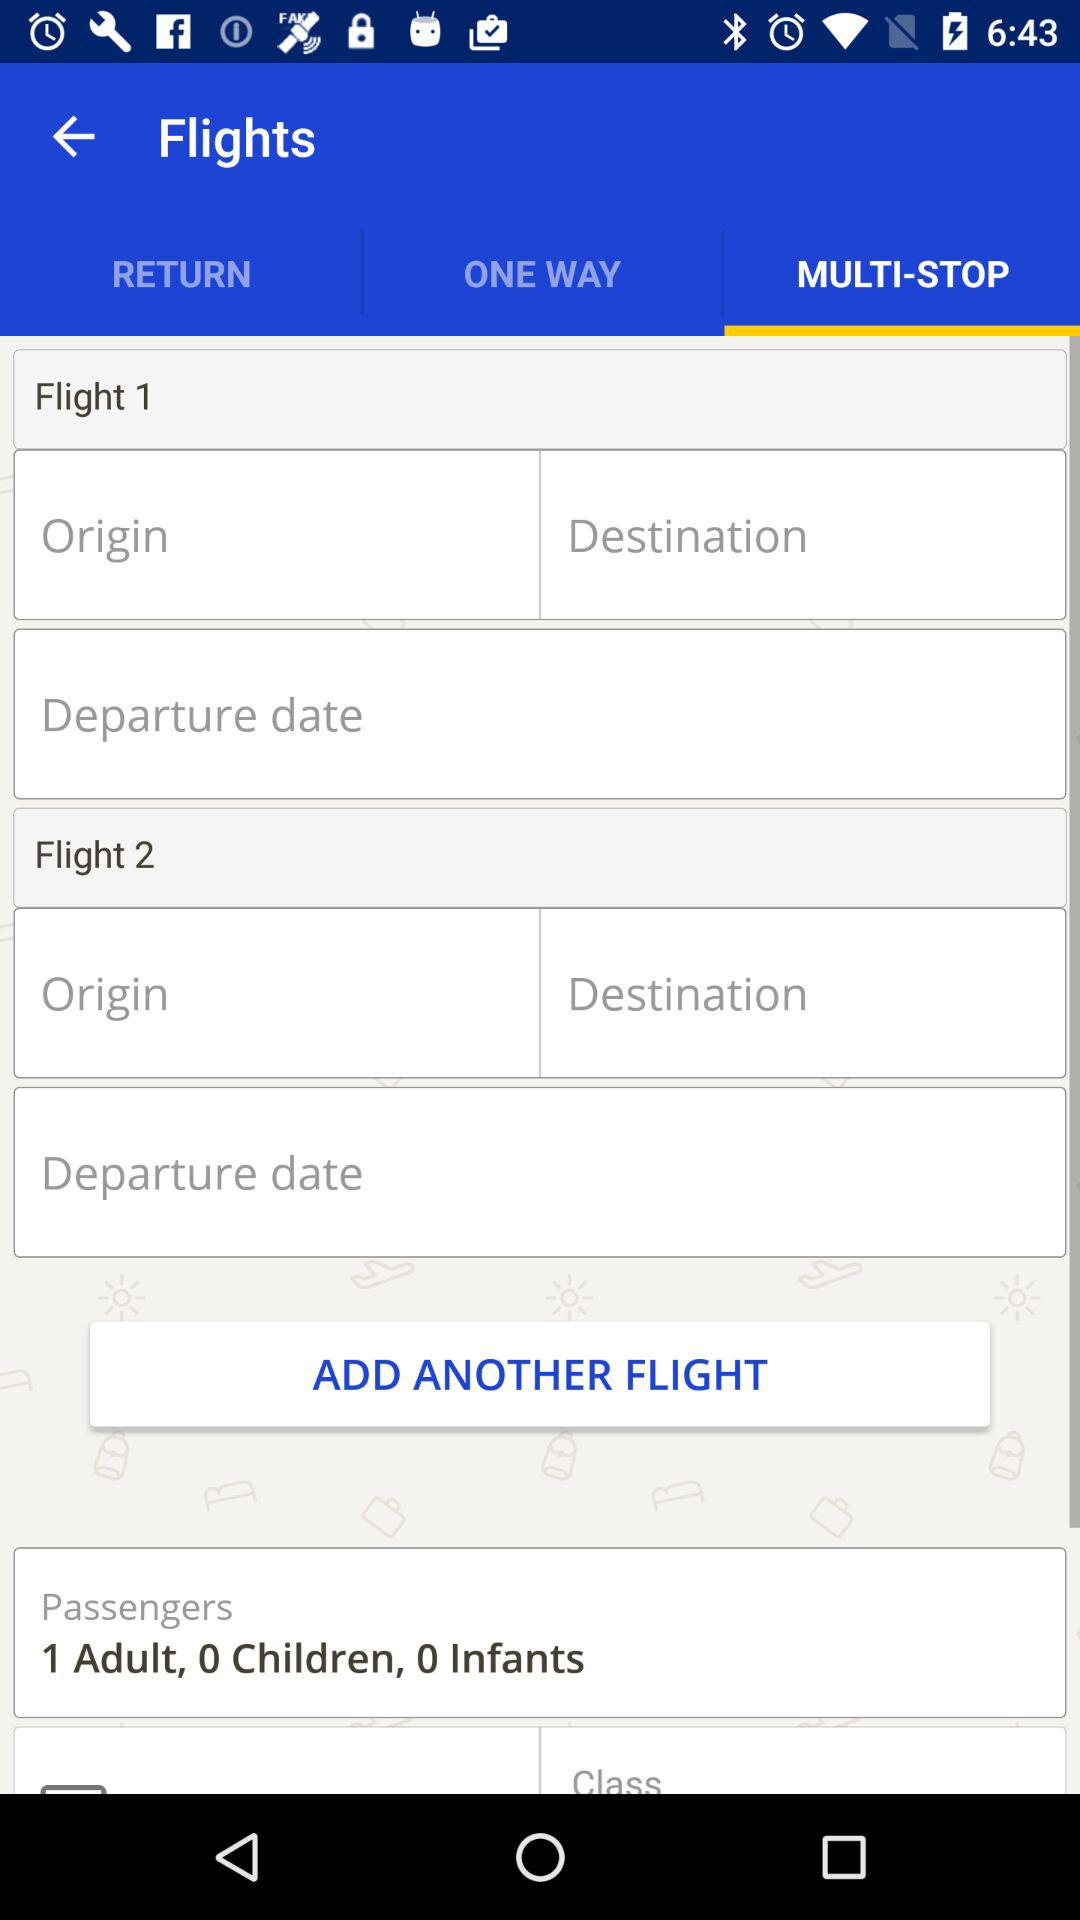How many passengers are traveling? There is 1 adult traveling. 